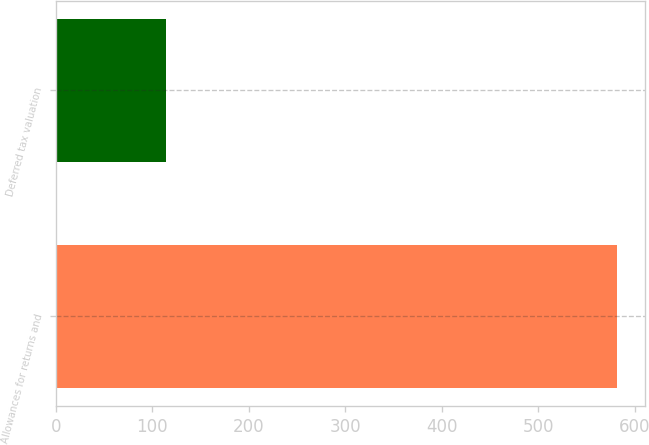Convert chart to OTSL. <chart><loc_0><loc_0><loc_500><loc_500><bar_chart><fcel>Allowances for returns and<fcel>Deferred tax valuation<nl><fcel>582<fcel>114<nl></chart> 